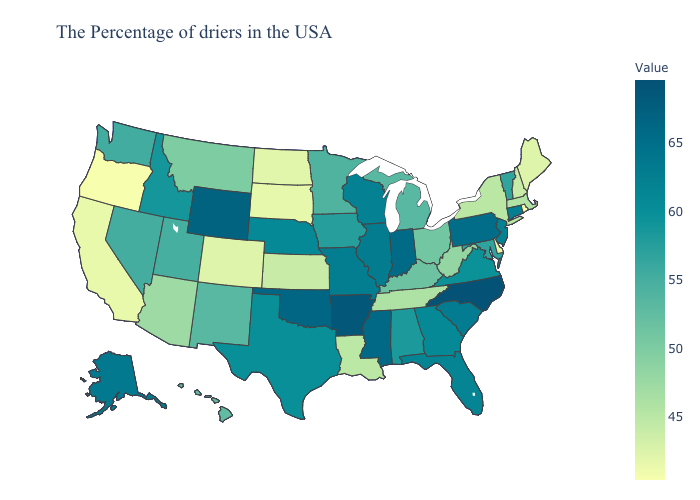Does Pennsylvania have the highest value in the Northeast?
Write a very short answer. Yes. Does Minnesota have the lowest value in the USA?
Keep it brief. No. Which states have the highest value in the USA?
Concise answer only. North Carolina. Does Oregon have the lowest value in the West?
Write a very short answer. Yes. Which states have the lowest value in the USA?
Concise answer only. Oregon. Does North Carolina have the highest value in the South?
Write a very short answer. Yes. Does Maryland have the highest value in the South?
Concise answer only. No. Among the states that border New Hampshire , which have the highest value?
Short answer required. Vermont. 